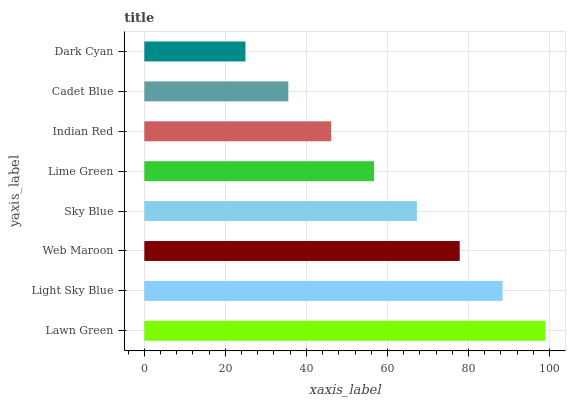Is Dark Cyan the minimum?
Answer yes or no. Yes. Is Lawn Green the maximum?
Answer yes or no. Yes. Is Light Sky Blue the minimum?
Answer yes or no. No. Is Light Sky Blue the maximum?
Answer yes or no. No. Is Lawn Green greater than Light Sky Blue?
Answer yes or no. Yes. Is Light Sky Blue less than Lawn Green?
Answer yes or no. Yes. Is Light Sky Blue greater than Lawn Green?
Answer yes or no. No. Is Lawn Green less than Light Sky Blue?
Answer yes or no. No. Is Sky Blue the high median?
Answer yes or no. Yes. Is Lime Green the low median?
Answer yes or no. Yes. Is Web Maroon the high median?
Answer yes or no. No. Is Lawn Green the low median?
Answer yes or no. No. 